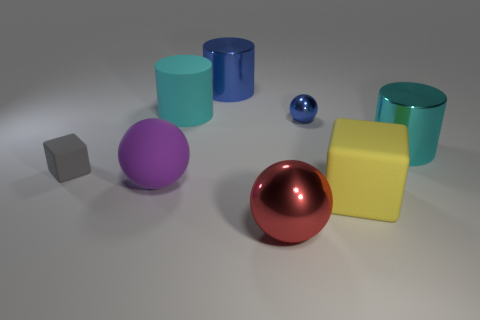Is the color of the big shiny thing in front of the large yellow thing the same as the small metallic thing?
Your answer should be very brief. No. There is a object on the left side of the purple sphere; what is its material?
Provide a succinct answer. Rubber. How big is the blue sphere?
Offer a terse response. Small. Are the big sphere to the left of the red shiny ball and the red sphere made of the same material?
Provide a short and direct response. No. How many cylinders are there?
Provide a short and direct response. 3. How many objects are either blue cylinders or cyan things?
Offer a terse response. 3. There is a large cyan cylinder on the right side of the metallic thing that is behind the large cyan rubber cylinder; how many tiny blue balls are in front of it?
Offer a very short reply. 0. Is there anything else of the same color as the large matte ball?
Your response must be concise. No. There is a large ball on the right side of the blue metallic cylinder; does it have the same color as the block that is on the left side of the cyan rubber cylinder?
Provide a succinct answer. No. Is the number of tiny blue shiny balls behind the small gray object greater than the number of small blue metal balls in front of the large yellow cube?
Your answer should be compact. Yes. 